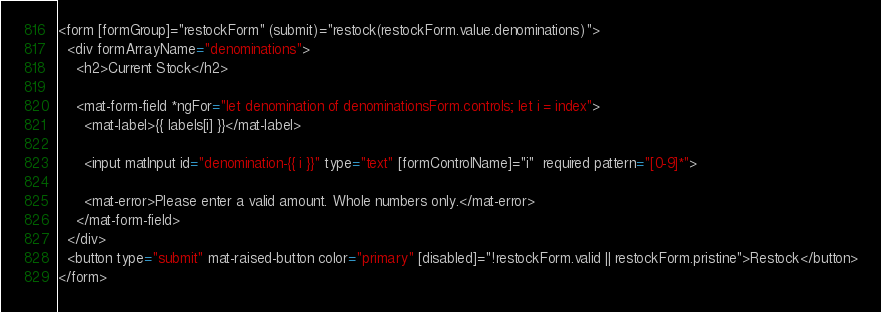<code> <loc_0><loc_0><loc_500><loc_500><_HTML_><form [formGroup]="restockForm" (submit)="restock(restockForm.value.denominations)">
  <div formArrayName="denominations">
    <h2>Current Stock</h2>

    <mat-form-field *ngFor="let denomination of denominationsForm.controls; let i = index">
      <mat-label>{{ labels[i] }}</mat-label>

      <input matInput id="denomination-{{ i }}" type="text" [formControlName]="i"  required pattern="[0-9]*">

      <mat-error>Please enter a valid amount. Whole numbers only.</mat-error>
    </mat-form-field>
  </div>
  <button type="submit" mat-raised-button color="primary" [disabled]="!restockForm.valid || restockForm.pristine">Restock</button>
</form>
</code> 